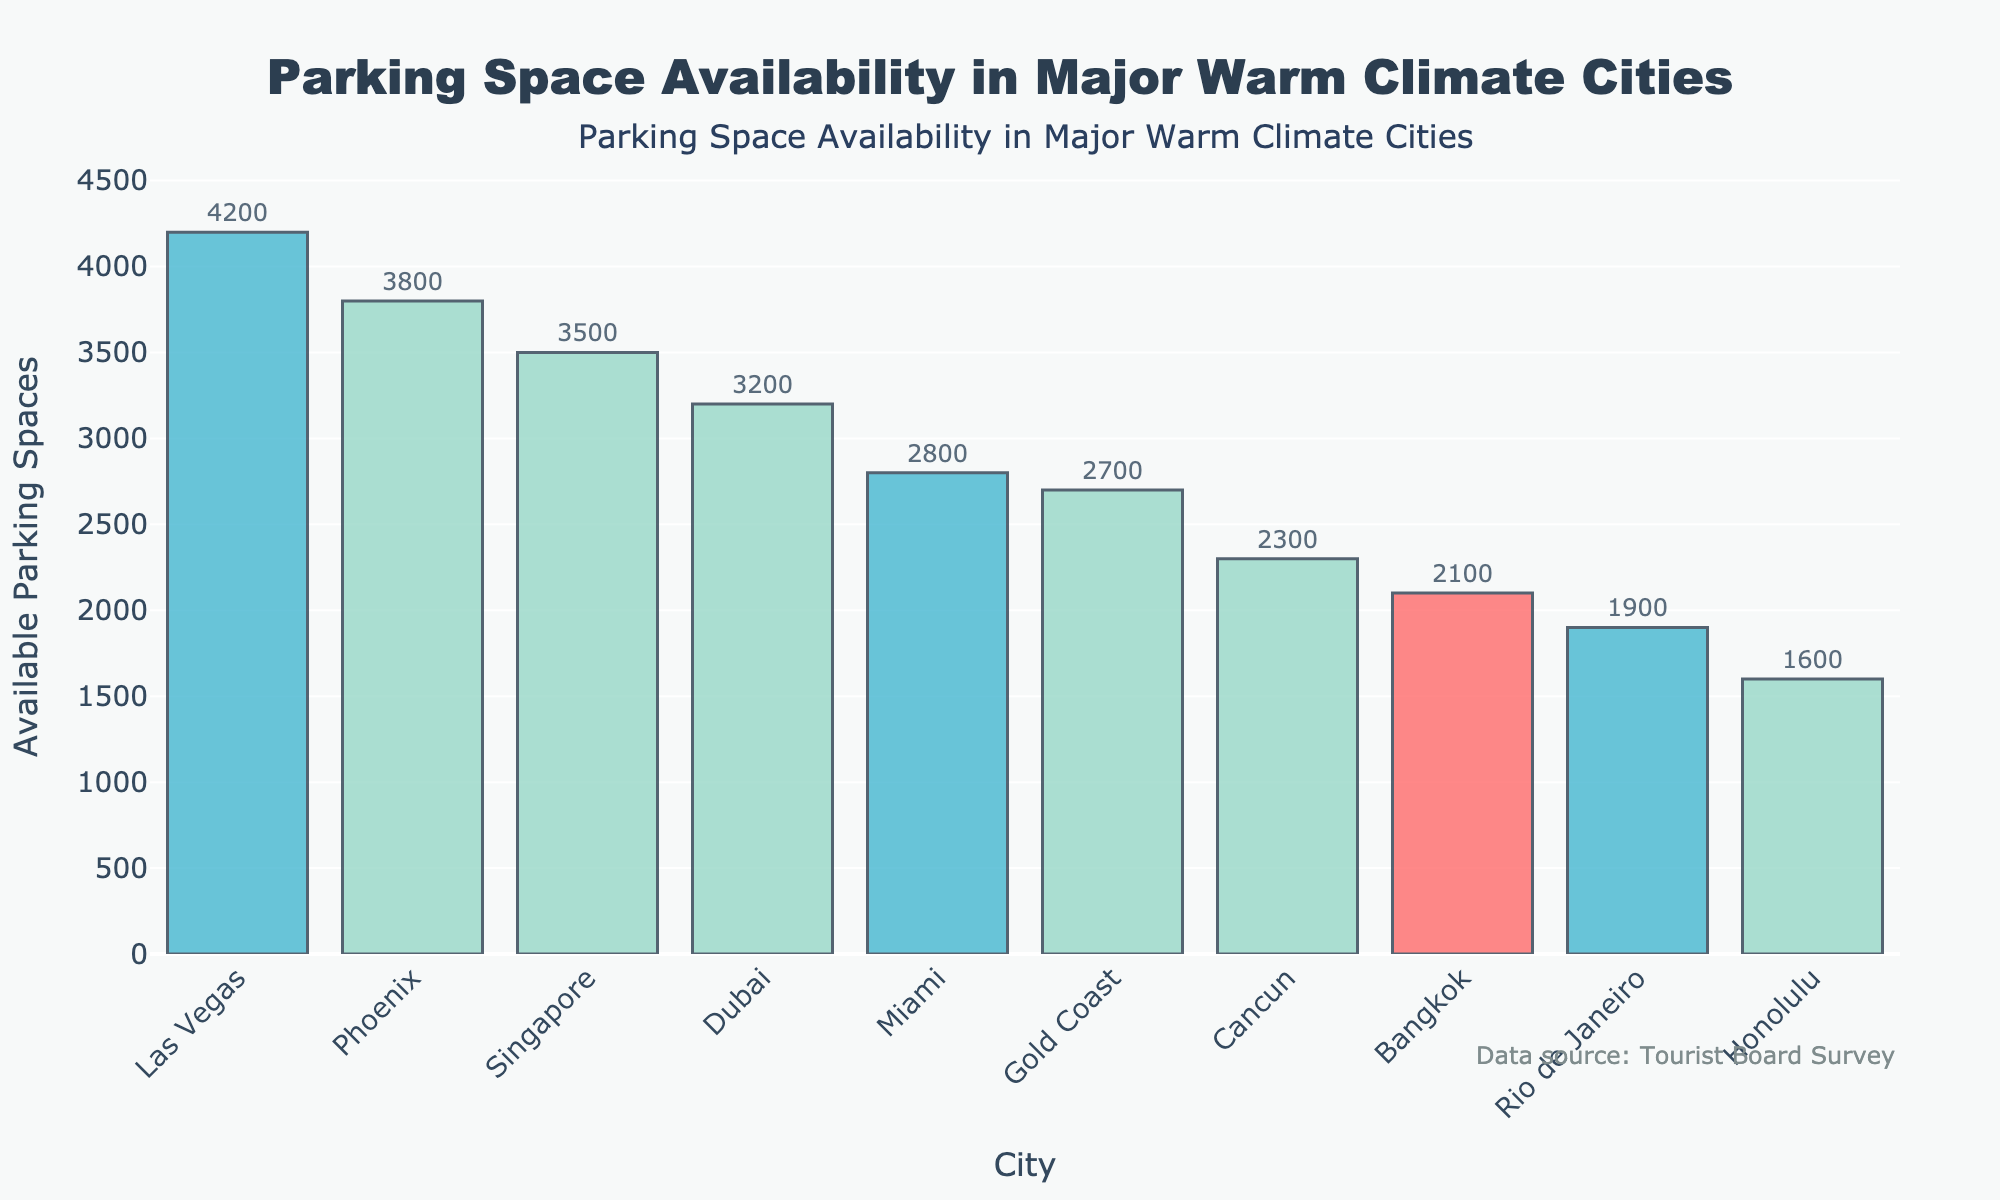what's the city with the highest number of available parking spaces? By looking at the height of the bars, the tallest bar represents Las Vegas.
Answer: Las Vegas What's the city with the lowest number of available parking spaces? By observing the shortest bar, the city associated with it is Honolulu.
Answer: Honolulu How many cities have more than 3000 available parking spaces? Count the bars whose height exceeds the 3000 mark on the y-axis. There are Las Vegas, Phoenix, Singapore, and Dubai.
Answer: 4 What is the difference in available parking spaces between Miami and Cancun? Look at the top of Miami and Cancun bars: Miami has 2800 and Cancun has 2300. The difference is 2800 - 2300.
Answer: 500 Which city has slightly fewer available parking spaces than Phoenix? By identifying the bar just below Phoenix's, the city is Singapore.
Answer: Singapore What's the sum of available parking spaces for Gold Coast, Bangkok, and Rio de Janeiro? Look at each of these cities' bars: Gold Coast has 2700, Bangkok has 2100, and Rio de Janeiro has 1900. Add them together: 2700 + 2100 + 1900.
Answer: 6700 What is the median number of available parking spaces among all cities? Sort the list of parking spaces and find the median. The sorted list is 1600, 1900, 2100, 2300, 2700, 2800, 3200, 3500, 3800, 4200. The median is the average of the 5th and 6th values: (2700 + 2800) / 2.
Answer: 2750 What city has more available parking spaces, Bangkok or Cancun? Compare the heights of Bangkok and Cancun bars. Bangkok has 2100 while Cancun has 2300.
Answer: Cancun Which cities have less than 2000 available parking spaces? Identify the bars that do not exceed the 2000 mark. These cities are Rio de Janeiro and Honolulu.
Answer: Rio de Janeiro, Honolulu 